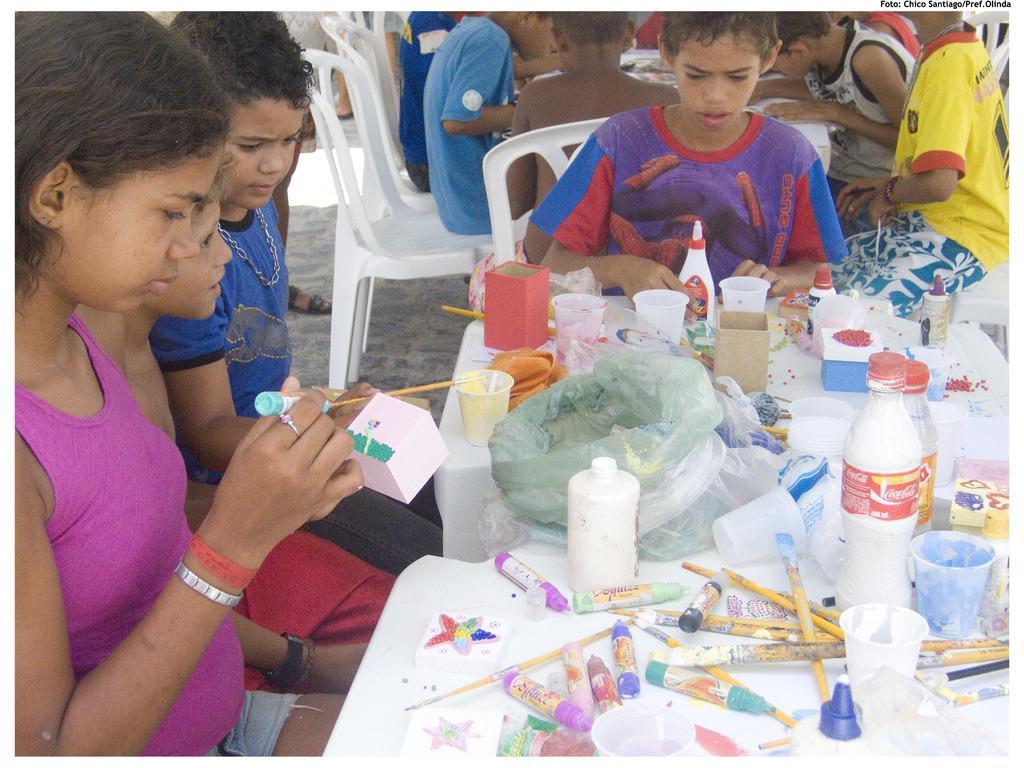Describe this image in one or two sentences. In this picture we can see a group of people sitting on chairs and in front of them on tables we can see bottles, glasses, sketch pens, paint brushes, plastic covers, some objects and in the background we can see a person's leg on the floor. 